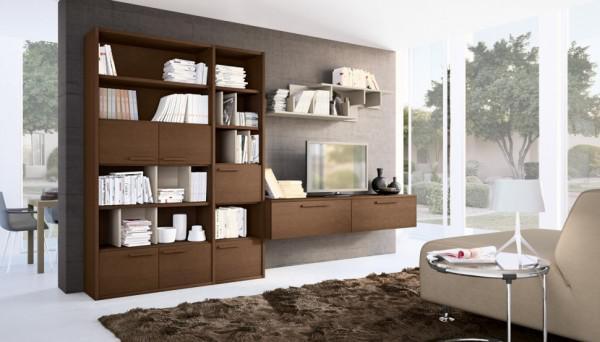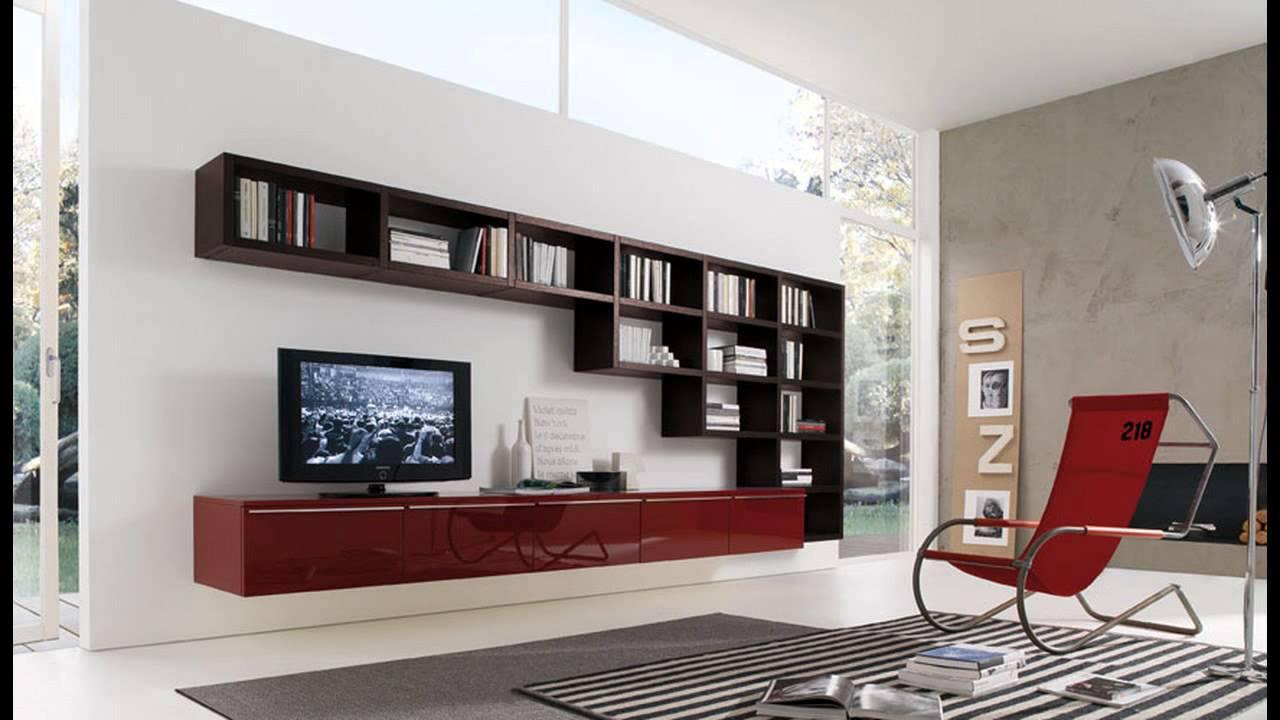The first image is the image on the left, the second image is the image on the right. Examine the images to the left and right. Is the description "The lamp in the image on the left is sitting on a table." accurate? Answer yes or no. Yes. The first image is the image on the left, the second image is the image on the right. Examine the images to the left and right. Is the description "One image shows a room with black bookshelves along one side of a storage unit, with a TV in the center and glass-fronted squares opposite the bookshelves." accurate? Answer yes or no. No. 